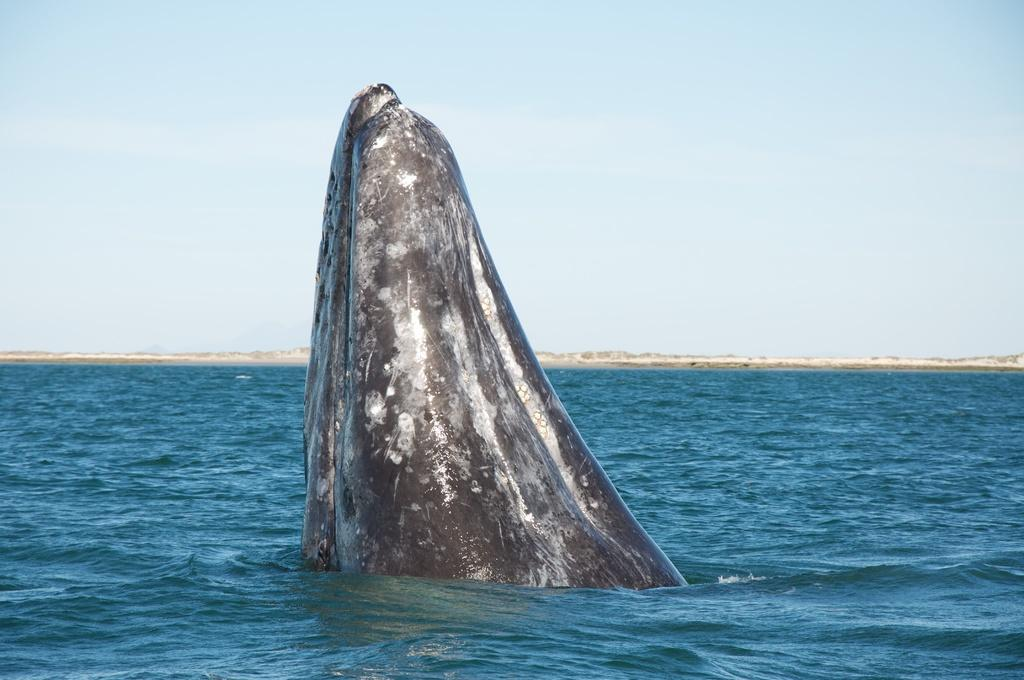What is the main subject in the center of the image? There is a whale in the center of the image. What is the environment in which the whale is situated? The whale is in the water. What can be seen in the background of the image? There is sky visible in the background of the image. What type of sheet is covering the whale in the image? There is no sheet covering the whale in the image; it is in the water. What time of day is depicted in the image? The time of day is not specified in the image, as only the sky is visible in the background. 